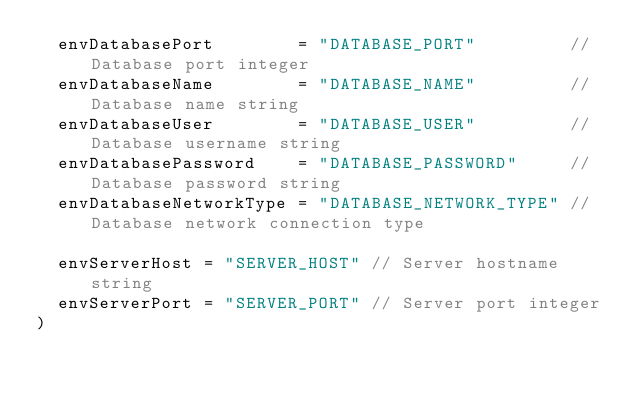<code> <loc_0><loc_0><loc_500><loc_500><_Go_>	envDatabasePort        = "DATABASE_PORT"         // Database port integer
	envDatabaseName        = "DATABASE_NAME"         // Database name string
	envDatabaseUser        = "DATABASE_USER"         // Database username string
	envDatabasePassword    = "DATABASE_PASSWORD"     // Database password string
	envDatabaseNetworkType = "DATABASE_NETWORK_TYPE" // Database network connection type

	envServerHost = "SERVER_HOST" // Server hostname string
	envServerPort = "SERVER_PORT" // Server port integer
)
</code> 